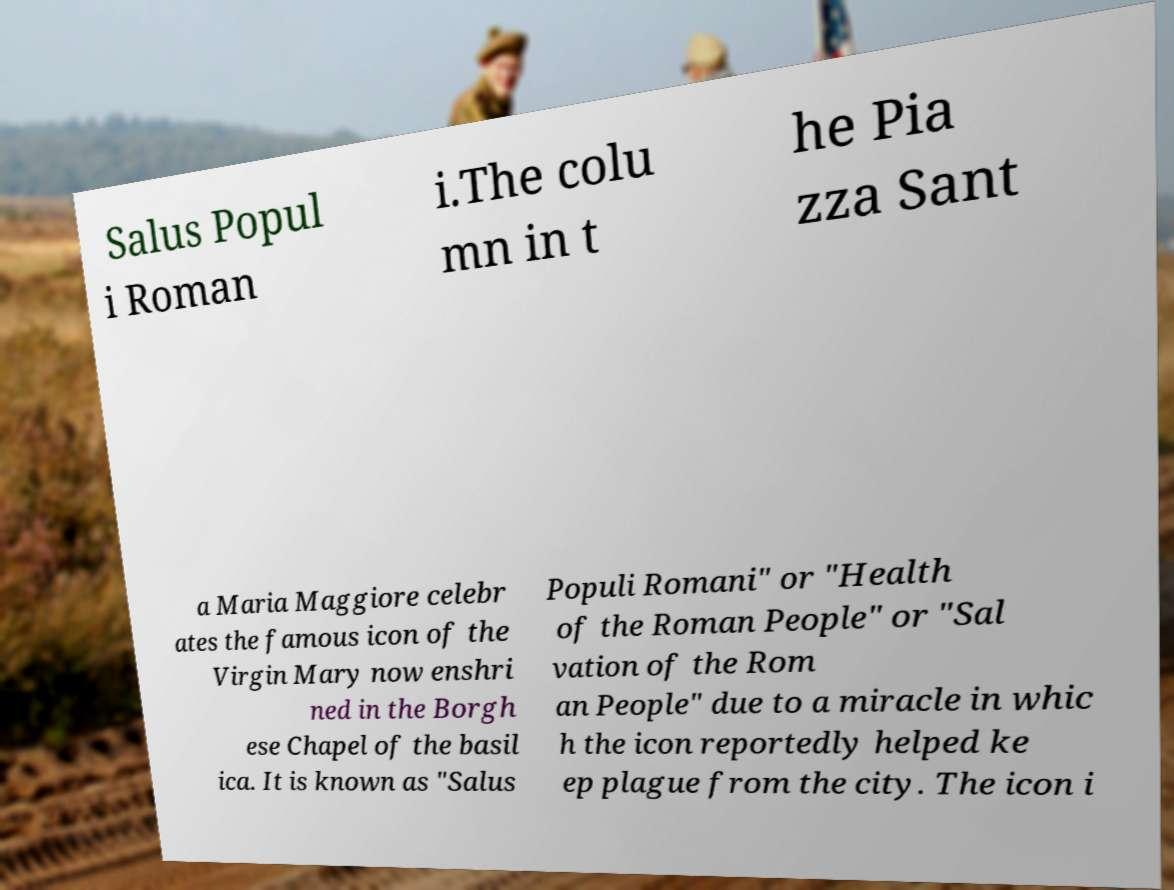What messages or text are displayed in this image? I need them in a readable, typed format. Salus Popul i Roman i.The colu mn in t he Pia zza Sant a Maria Maggiore celebr ates the famous icon of the Virgin Mary now enshri ned in the Borgh ese Chapel of the basil ica. It is known as "Salus Populi Romani" or "Health of the Roman People" or "Sal vation of the Rom an People" due to a miracle in whic h the icon reportedly helped ke ep plague from the city. The icon i 